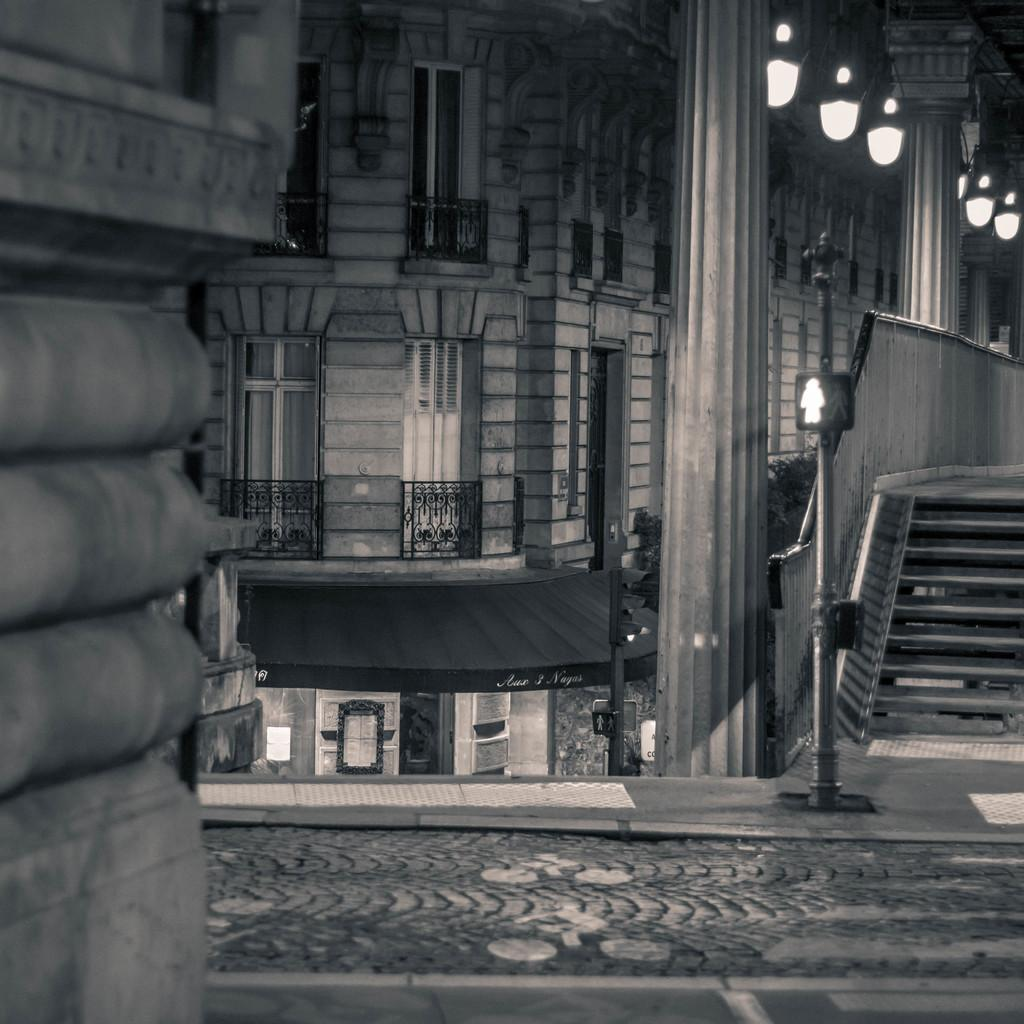What type of structure is present in the image? There is a building in the image. What can be seen illuminated in the image? There are lights visible in the image. What are the tall, slender objects in the image? There are poles in the image. Can you describe any other objects in the image? There are some objects in the image. What type of beetle can be seen crawling on the building in the image? There is no beetle present in the image; it only features a building, lights, poles, and other objects. 